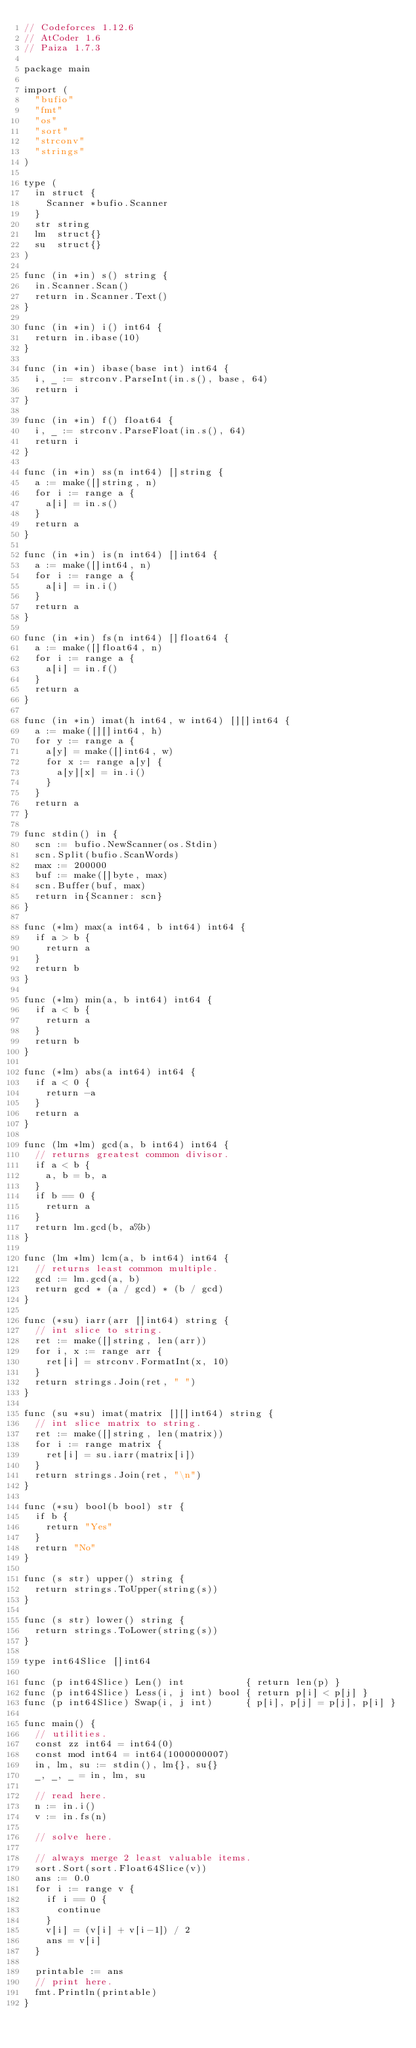Convert code to text. <code><loc_0><loc_0><loc_500><loc_500><_Go_>// Codeforces 1.12.6
// AtCoder 1.6
// Paiza 1.7.3

package main

import (
	"bufio"
	"fmt"
	"os"
	"sort"
	"strconv"
	"strings"
)

type (
	in struct {
		Scanner *bufio.Scanner
	}
	str string
	lm  struct{}
	su  struct{}
)

func (in *in) s() string {
	in.Scanner.Scan()
	return in.Scanner.Text()
}

func (in *in) i() int64 {
	return in.ibase(10)
}

func (in *in) ibase(base int) int64 {
	i, _ := strconv.ParseInt(in.s(), base, 64)
	return i
}

func (in *in) f() float64 {
	i, _ := strconv.ParseFloat(in.s(), 64)
	return i
}

func (in *in) ss(n int64) []string {
	a := make([]string, n)
	for i := range a {
		a[i] = in.s()
	}
	return a
}

func (in *in) is(n int64) []int64 {
	a := make([]int64, n)
	for i := range a {
		a[i] = in.i()
	}
	return a
}

func (in *in) fs(n int64) []float64 {
	a := make([]float64, n)
	for i := range a {
		a[i] = in.f()
	}
	return a
}

func (in *in) imat(h int64, w int64) [][]int64 {
	a := make([][]int64, h)
	for y := range a {
		a[y] = make([]int64, w)
		for x := range a[y] {
			a[y][x] = in.i()
		}
	}
	return a
}

func stdin() in {
	scn := bufio.NewScanner(os.Stdin)
	scn.Split(bufio.ScanWords)
	max := 200000
	buf := make([]byte, max)
	scn.Buffer(buf, max)
	return in{Scanner: scn}
}

func (*lm) max(a int64, b int64) int64 {
	if a > b {
		return a
	}
	return b
}

func (*lm) min(a, b int64) int64 {
	if a < b {
		return a
	}
	return b
}

func (*lm) abs(a int64) int64 {
	if a < 0 {
		return -a
	}
	return a
}

func (lm *lm) gcd(a, b int64) int64 {
	// returns greatest common divisor.
	if a < b {
		a, b = b, a
	}
	if b == 0 {
		return a
	}
	return lm.gcd(b, a%b)
}

func (lm *lm) lcm(a, b int64) int64 {
	// returns least common multiple.
	gcd := lm.gcd(a, b)
	return gcd * (a / gcd) * (b / gcd)
}

func (*su) iarr(arr []int64) string {
	// int slice to string.
	ret := make([]string, len(arr))
	for i, x := range arr {
		ret[i] = strconv.FormatInt(x, 10)
	}
	return strings.Join(ret, " ")
}

func (su *su) imat(matrix [][]int64) string {
	// int slice matrix to string.
	ret := make([]string, len(matrix))
	for i := range matrix {
		ret[i] = su.iarr(matrix[i])
	}
	return strings.Join(ret, "\n")
}

func (*su) bool(b bool) str {
	if b {
		return "Yes"
	}
	return "No"
}

func (s str) upper() string {
	return strings.ToUpper(string(s))
}

func (s str) lower() string {
	return strings.ToLower(string(s))
}

type int64Slice []int64

func (p int64Slice) Len() int           { return len(p) }
func (p int64Slice) Less(i, j int) bool { return p[i] < p[j] }
func (p int64Slice) Swap(i, j int)      { p[i], p[j] = p[j], p[i] }

func main() {
	// utilities.
	const zz int64 = int64(0)
	const mod int64 = int64(1000000007)
	in, lm, su := stdin(), lm{}, su{}
	_, _, _ = in, lm, su

	// read here.
	n := in.i()
	v := in.fs(n)

	// solve here.

	// always merge 2 least valuable items.
	sort.Sort(sort.Float64Slice(v))
	ans := 0.0
	for i := range v {
		if i == 0 {
			continue
		}
		v[i] = (v[i] + v[i-1]) / 2
		ans = v[i]
	}

	printable := ans
	// print here.
	fmt.Println(printable)
}
</code> 